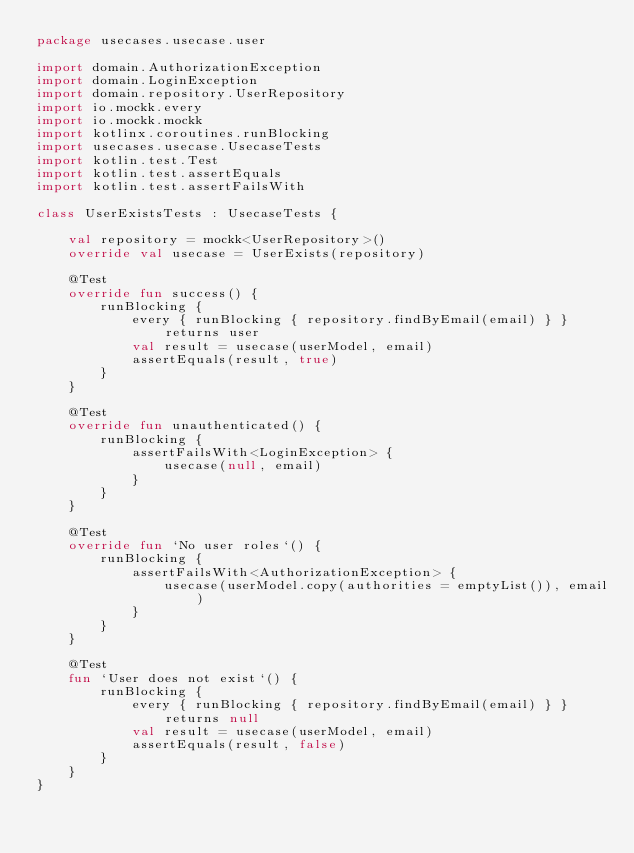Convert code to text. <code><loc_0><loc_0><loc_500><loc_500><_Kotlin_>package usecases.usecase.user

import domain.AuthorizationException
import domain.LoginException
import domain.repository.UserRepository
import io.mockk.every
import io.mockk.mockk
import kotlinx.coroutines.runBlocking
import usecases.usecase.UsecaseTests
import kotlin.test.Test
import kotlin.test.assertEquals
import kotlin.test.assertFailsWith

class UserExistsTests : UsecaseTests {

    val repository = mockk<UserRepository>()
    override val usecase = UserExists(repository)

    @Test
    override fun success() {
        runBlocking {
            every { runBlocking { repository.findByEmail(email) } } returns user
            val result = usecase(userModel, email)
            assertEquals(result, true)
        }
    }

    @Test
    override fun unauthenticated() {
        runBlocking {
            assertFailsWith<LoginException> {
                usecase(null, email)
            }
        }
    }

    @Test
    override fun `No user roles`() {
        runBlocking {
            assertFailsWith<AuthorizationException> {
                usecase(userModel.copy(authorities = emptyList()), email)
            }
        }
    }

    @Test
    fun `User does not exist`() {
        runBlocking {
            every { runBlocking { repository.findByEmail(email) } } returns null
            val result = usecase(userModel, email)
            assertEquals(result, false)
        }
    }
}
</code> 